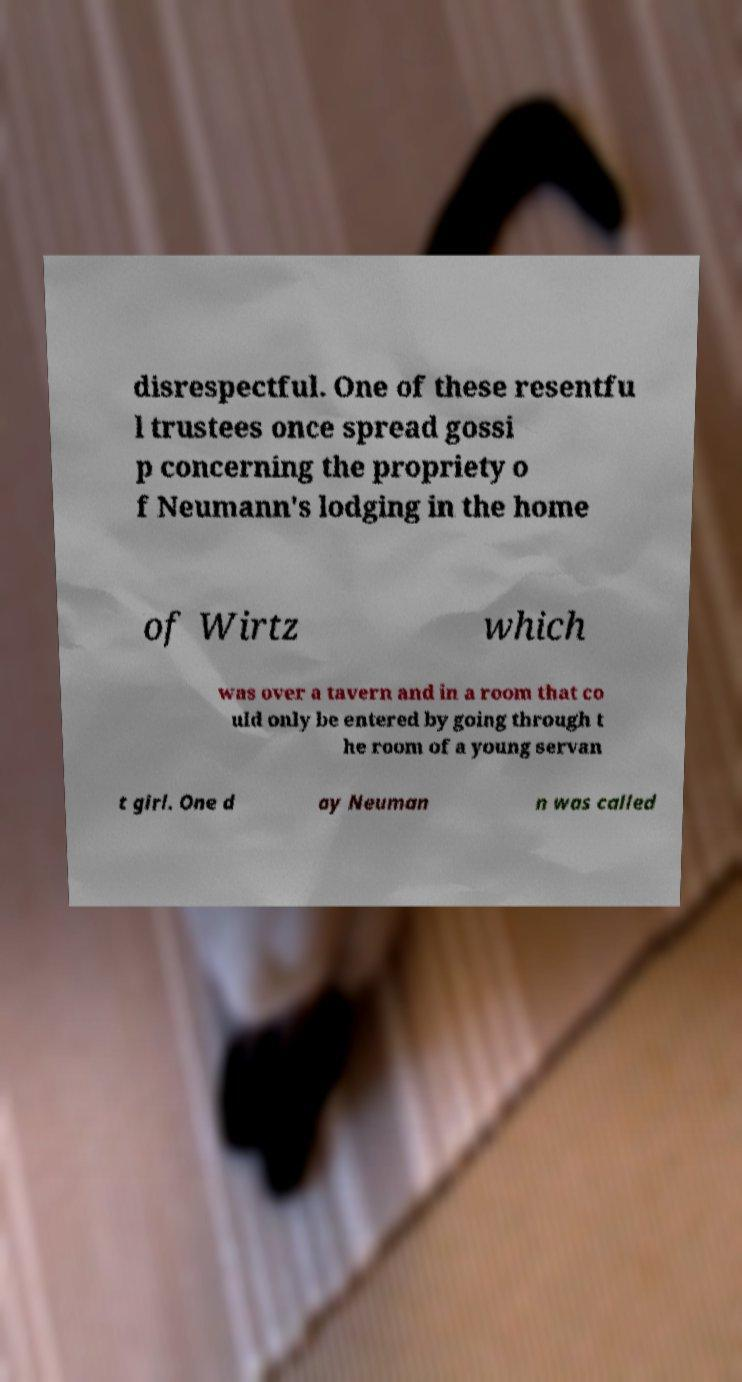Could you assist in decoding the text presented in this image and type it out clearly? disrespectful. One of these resentfu l trustees once spread gossi p concerning the propriety o f Neumann's lodging in the home of Wirtz which was over a tavern and in a room that co uld only be entered by going through t he room of a young servan t girl. One d ay Neuman n was called 